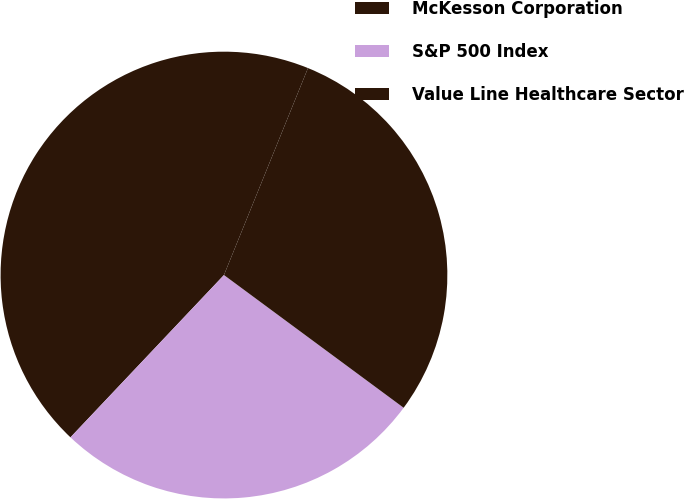Convert chart to OTSL. <chart><loc_0><loc_0><loc_500><loc_500><pie_chart><fcel>McKesson Corporation<fcel>S&P 500 Index<fcel>Value Line Healthcare Sector<nl><fcel>44.08%<fcel>26.93%<fcel>28.99%<nl></chart> 